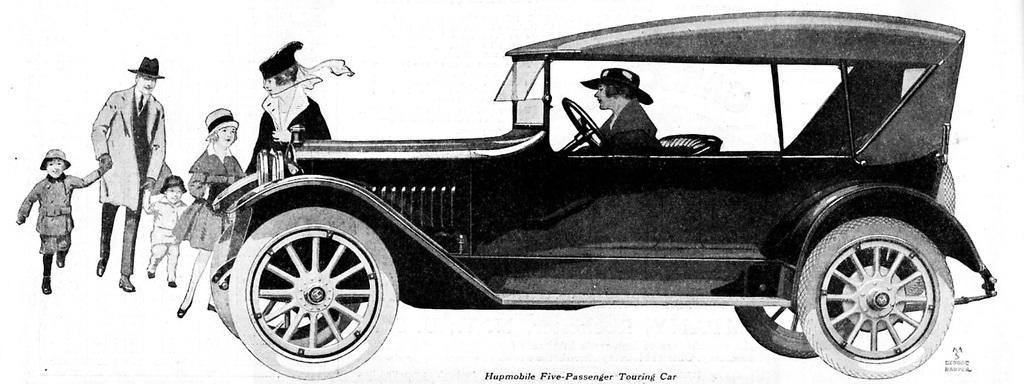Can you describe this image briefly? Here we can see a cartoon image, in this picture we can see a car, on the left side there are five persons standing here, we can see one more person sitting in the car, at the bottom there is some text. 